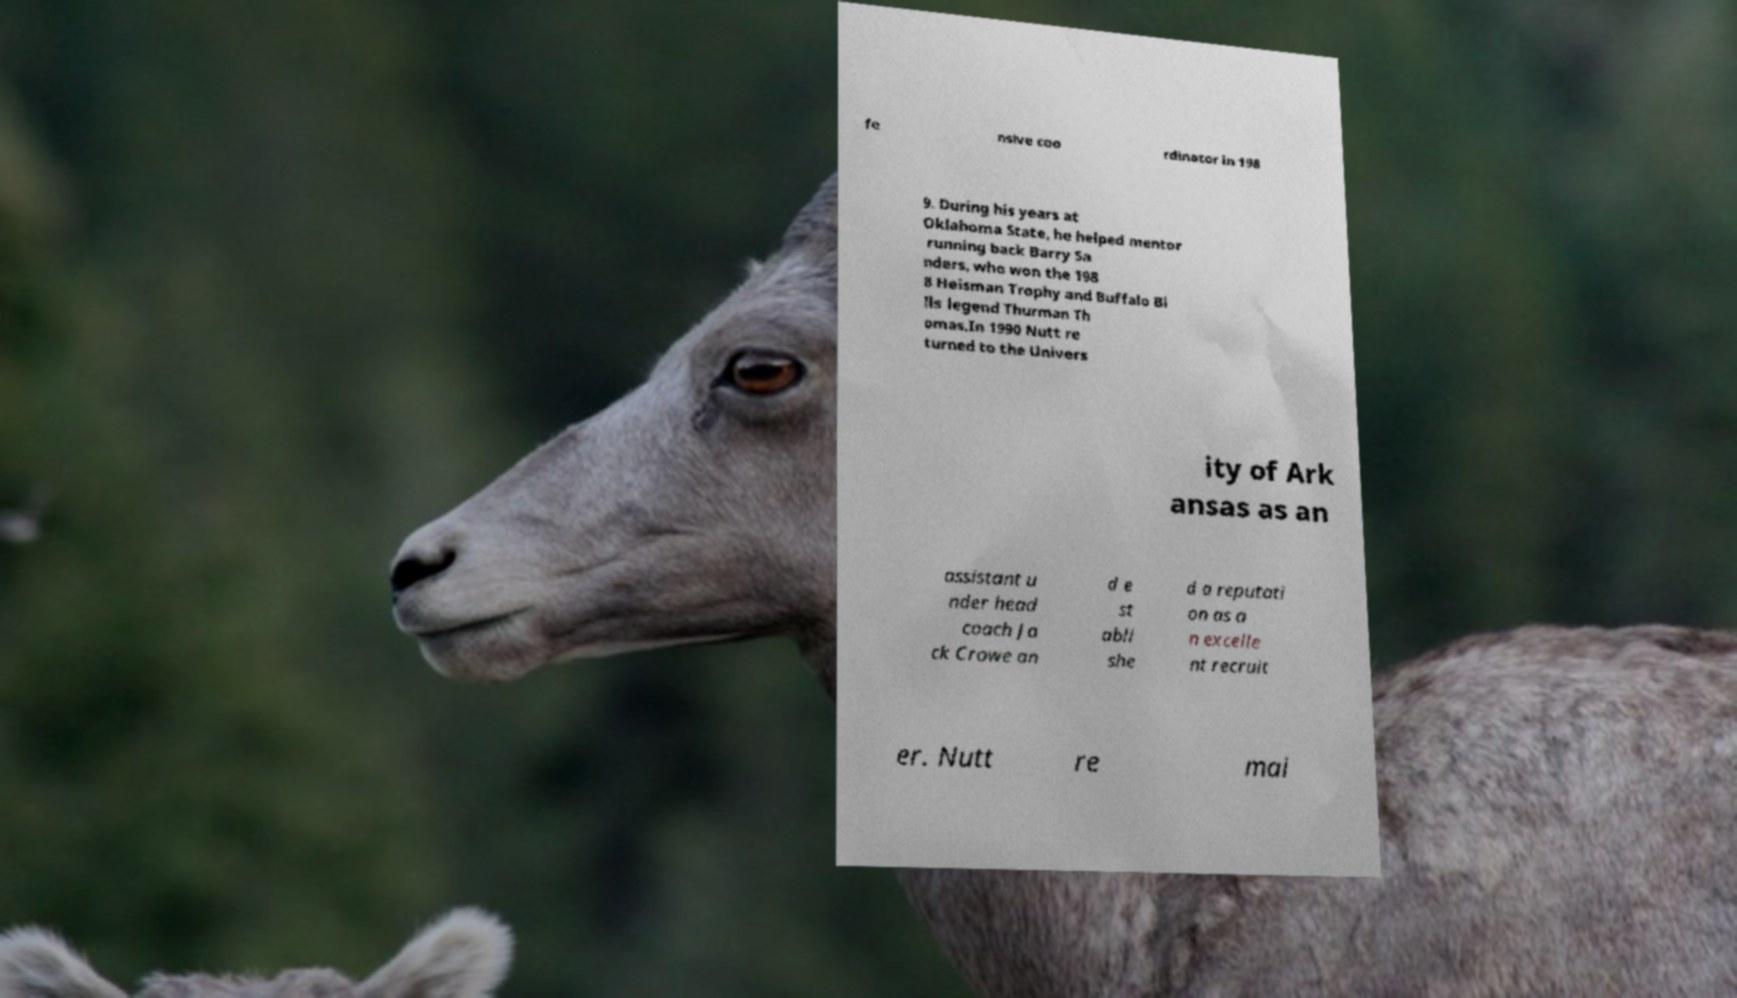I need the written content from this picture converted into text. Can you do that? fe nsive coo rdinator in 198 9. During his years at Oklahoma State, he helped mentor running back Barry Sa nders, who won the 198 8 Heisman Trophy and Buffalo Bi lls legend Thurman Th omas.In 1990 Nutt re turned to the Univers ity of Ark ansas as an assistant u nder head coach Ja ck Crowe an d e st abli she d a reputati on as a n excelle nt recruit er. Nutt re mai 